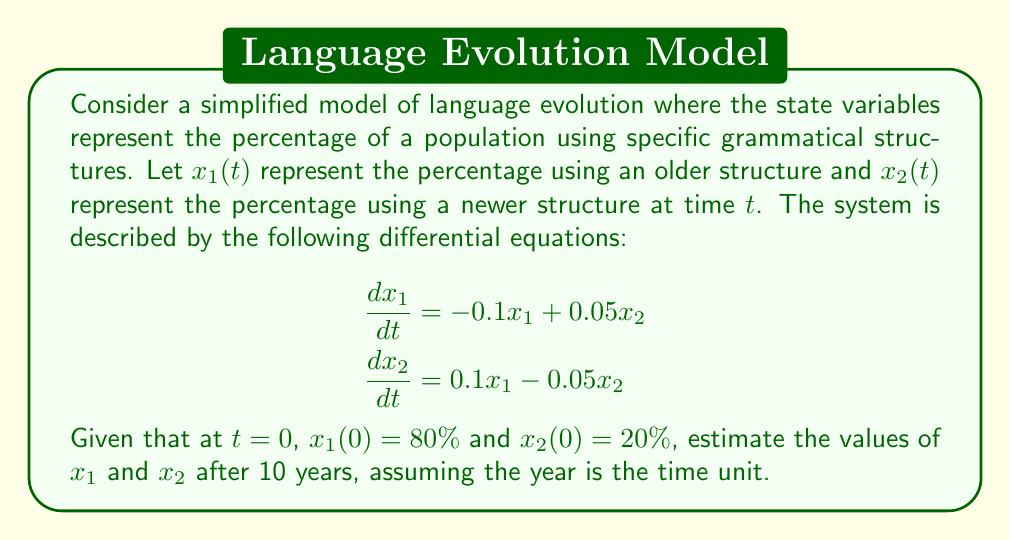Solve this math problem. To solve this problem, we need to use the state-space representation of the system and apply the matrix exponential method. Let's break it down step by step:

1) First, we write the system in matrix form:

   $$\frac{d}{dt}\begin{bmatrix} x_1 \\ x_2 \end{bmatrix} = \begin{bmatrix} -0.1 & 0.05 \\ 0.1 & -0.05 \end{bmatrix} \begin{bmatrix} x_1 \\ x_2 \end{bmatrix}$$

2) Let's call the matrix $A = \begin{bmatrix} -0.1 & 0.05 \\ 0.1 & -0.05 \end{bmatrix}$

3) The solution to this system is given by:

   $$\begin{bmatrix} x_1(t) \\ x_2(t) \end{bmatrix} = e^{At} \begin{bmatrix} x_1(0) \\ x_2(0) \end{bmatrix}$$

4) To compute $e^{At}$, we need to find the eigenvalues and eigenvectors of $A$:

   Characteristic equation: $\det(A - \lambda I) = \lambda^2 + 0.15\lambda = 0$
   Eigenvalues: $\lambda_1 = 0$, $\lambda_2 = -0.15$

5) The eigenvectors are:
   
   For $\lambda_1 = 0$: $v_1 = \begin{bmatrix} 1 \\ 2 \end{bmatrix}$
   For $\lambda_2 = -0.15$: $v_2 = \begin{bmatrix} 1 \\ -1 \end{bmatrix}$

6) Now we can write $e^{At}$:

   $$e^{At} = c_1v_1 + c_2v_2e^{-0.15t} = \begin{bmatrix} 1 & 1 \\ 2 & -1 \end{bmatrix} \begin{bmatrix} 1 & 0 \\ 0 & e^{-0.15t} \end{bmatrix} \begin{bmatrix} 1 & 1 \\ 2 & -1 \end{bmatrix}^{-1}$$

7) Simplifying:

   $$e^{At} = \frac{1}{3} \begin{bmatrix} 2+e^{-0.15t} & 1-e^{-0.15t} \\ 2-2e^{-0.15t} & 1+2e^{-0.15t} \end{bmatrix}$$

8) Now we can compute the state at $t=10$:

   $$\begin{bmatrix} x_1(10) \\ x_2(10) \end{bmatrix} = \frac{1}{3} \begin{bmatrix} 2+e^{-1.5} & 1-e^{-1.5} \\ 2-2e^{-1.5} & 1+2e^{-1.5} \end{bmatrix} \begin{bmatrix} 80 \\ 20 \end{bmatrix}$$

9) Calculating:

   $$\begin{bmatrix} x_1(10) \\ x_2(10) \end{bmatrix} \approx \begin{bmatrix} 70.22 \\ 29.78 \end{bmatrix}$$

Therefore, after 10 years, approximately 70.22% of the population will use the older structure, and 29.78% will use the newer structure.
Answer: After 10 years:
$x_1(10) \approx 70.22\%$
$x_2(10) \approx 29.78\%$ 